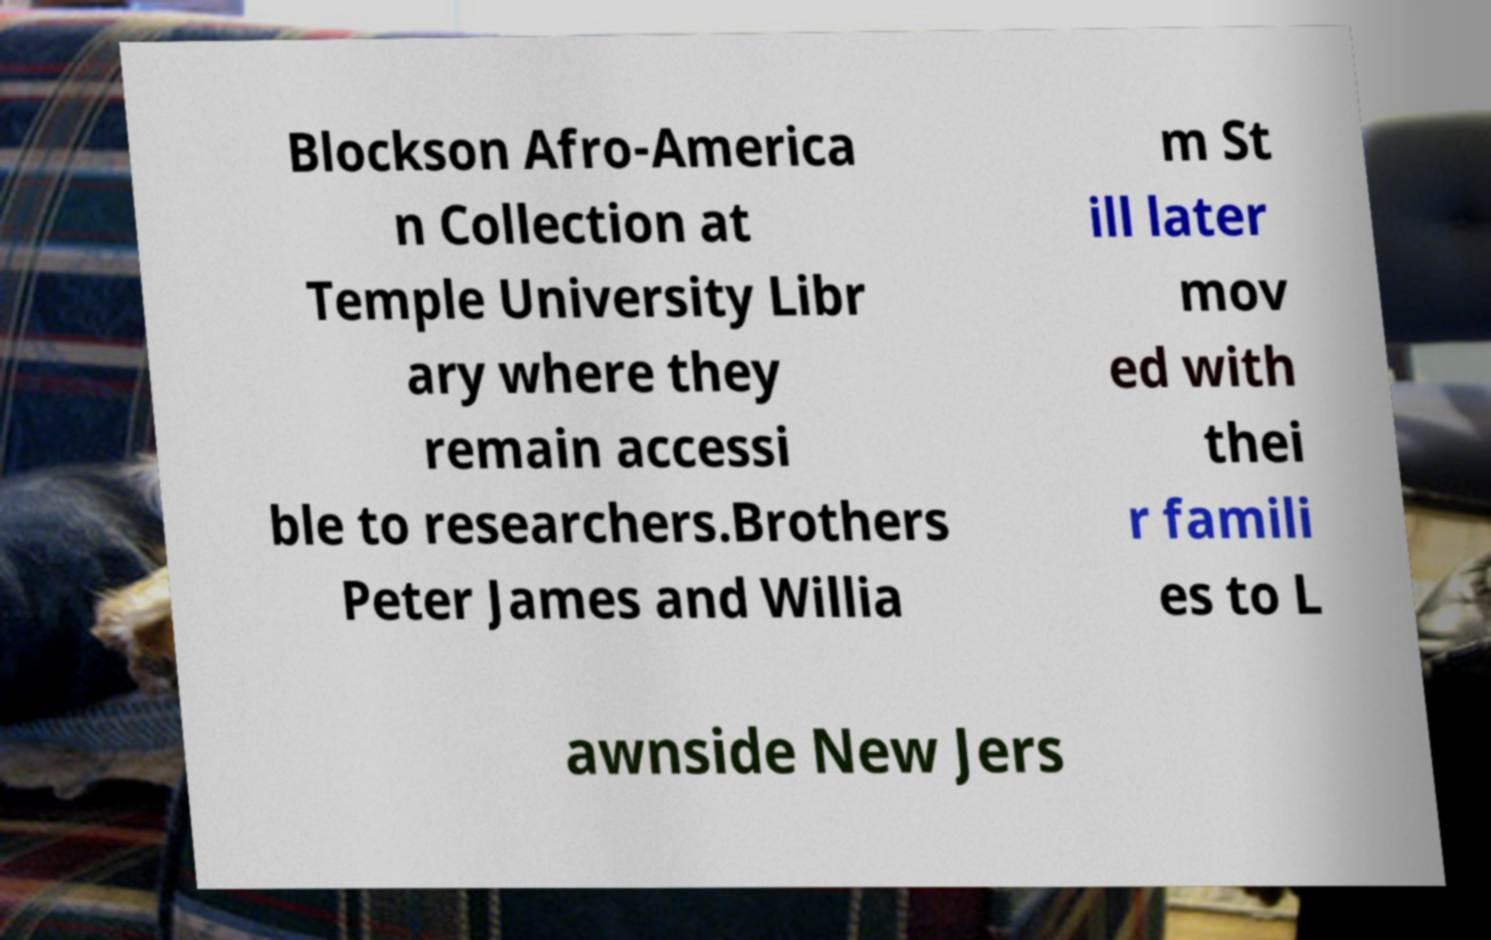Can you accurately transcribe the text from the provided image for me? Blockson Afro-America n Collection at Temple University Libr ary where they remain accessi ble to researchers.Brothers Peter James and Willia m St ill later mov ed with thei r famili es to L awnside New Jers 